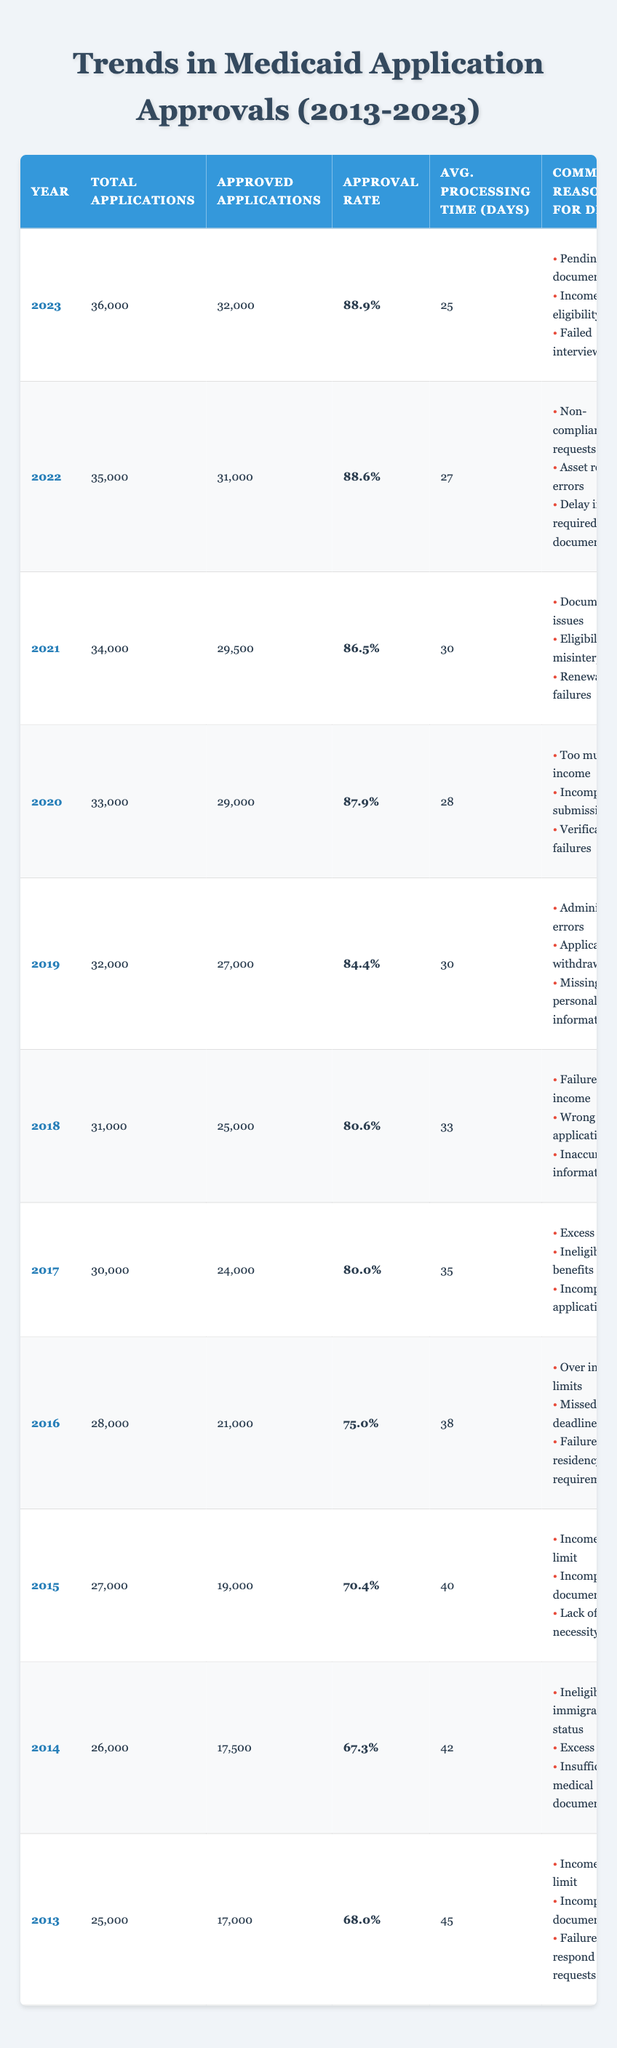What was the approval rate for Medicaid applications in 2020? In the table, we can find the row for the year 2020, which shows an approval rate of 87.9%.
Answer: 87.9% How many total applications were there in 2017? Looking at the year 2017 in the table, the total number of applications is listed as 30,000.
Answer: 30,000 What is the average processing time for approved applications in 2023? The table indicates that the average processing time for applications in 2023 is 25 days.
Answer: 25 days What is the difference in approval rates between 2013 and 2023? The approval rate in 2013 is 68.0%, and in 2023 it is 88.9%. The difference is calculated as 88.9% - 68.0% = 20.9%.
Answer: 20.9% Which year had the lowest average processing time and what was it? By scanning the table, we find that 2023 has the lowest average processing time of 25 days.
Answer: 25 days Was the approval rate higher in 2022 than in 2020? In 2022, the approval rate is 88.6%, while in 2020 it is 87.9%. Since 88.6% is greater than 87.9%, the statement is true.
Answer: Yes How many more approved applications were there in 2021 compared to 2015? In 2021, there were 29,500 approved applications, and in 2015, there were 19,000. Therefore, the difference is 29,500 - 19,000 = 10,500.
Answer: 10,500 List the common reasons for denial in 2019. The table outlines the common reasons for denial in 2019 as: Administrative errors, Application withdrawn, and Missing personal information.
Answer: Administrative errors, Application withdrawn, Missing personal information In what year did the approval rate first surpass 80%? Reviewing the table, we observe that the approval rate first surpasses 80% in 2017, with an approval rate of 80.0%.
Answer: 2017 What was the total number of applications in the years with an approval rate above 80%? The years with approval rates above 80% are 2017 (30,000), 2018 (31,000), 2019 (32,000), 2020 (33,000), 2021 (34,000), 2022 (35,000), and 2023 (36,000). Summing these gives 30,000 + 31,000 + 32,000 + 33,000 + 34,000 + 35,000 + 36,000, which totals 231,000.
Answer: 231,000 What trend can be observed in the average processing times from 2013 to 2023? Analyzing the table, we see that the average processing times have decreased from 45 days in 2013 to 25 days in 2023, indicating a positive trend of faster processing.
Answer: Decrease in processing time What percentage of applications were approved in 2018? The table specifies that 25,000 out of 31,000 total applications were approved in 2018. To find the percentage, we calculate (25,000 / 31,000) * 100, which equals approximately 80.6%.
Answer: 80.6% How do the common reasons for denial differ between 2013 and 2022? In 2013, the common reasons were Income above limit, Incomplete documentation, and Failure to respond to requests. In 2022, they were Non-compliance with requests, Asset reporting errors, and Delay in required documents. This shows a shift in the reasons for denial over the years.
Answer: Different reasons listed What was the average approval rate for the years 2015 to 2019? The approval rates from 2015 to 2019 are 70.4%, 75.0%, 80.0%, 80.6%, and 84.4%. Calculating the average: (70.4 + 75.0 + 80.0 + 80.6 + 84.4) / 5 = 78.08%.
Answer: 78.08% 